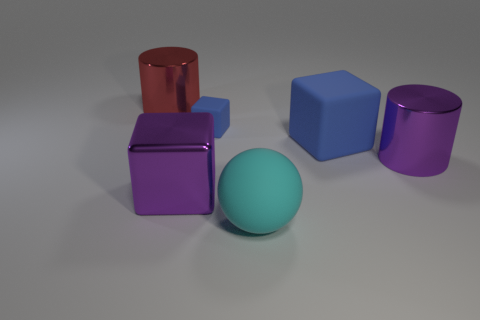Subtract all blue blocks. How many blocks are left? 1 Subtract all purple blocks. How many blocks are left? 2 Subtract all spheres. How many objects are left? 5 Subtract all green balls. How many gray cubes are left? 0 Add 2 purple cylinders. How many objects exist? 8 Subtract all large purple cylinders. Subtract all rubber objects. How many objects are left? 2 Add 2 rubber objects. How many rubber objects are left? 5 Add 3 big purple metal cylinders. How many big purple metal cylinders exist? 4 Subtract 0 gray balls. How many objects are left? 6 Subtract all blue balls. Subtract all yellow cylinders. How many balls are left? 1 